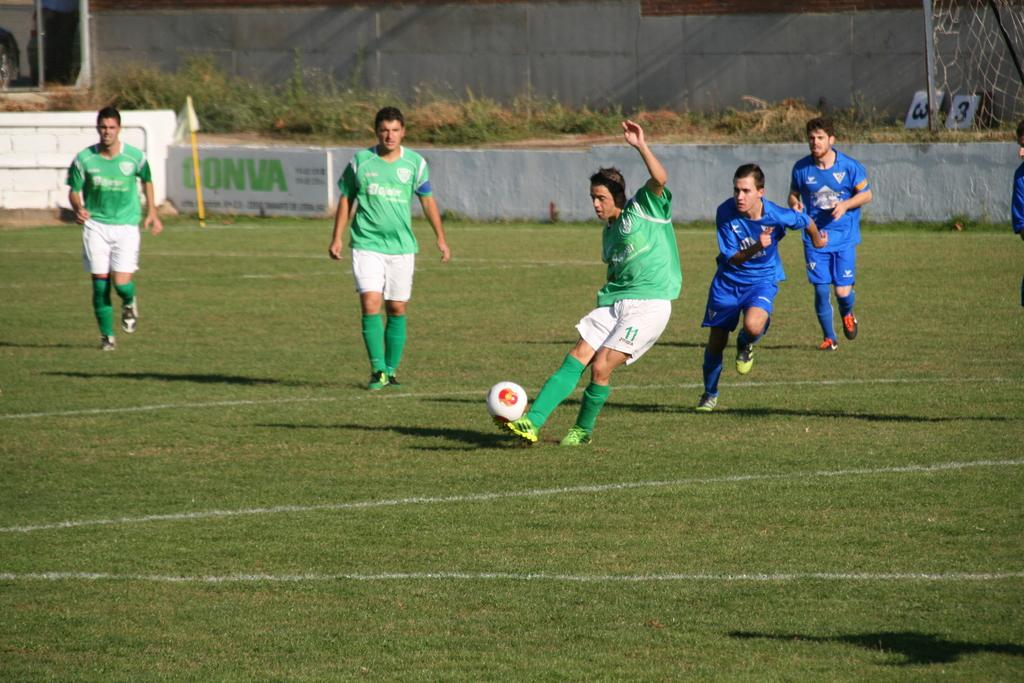<image>
Offer a succinct explanation of the picture presented. Two teams of soccer players  wearing a blue and a green uniform in a Conva field. 